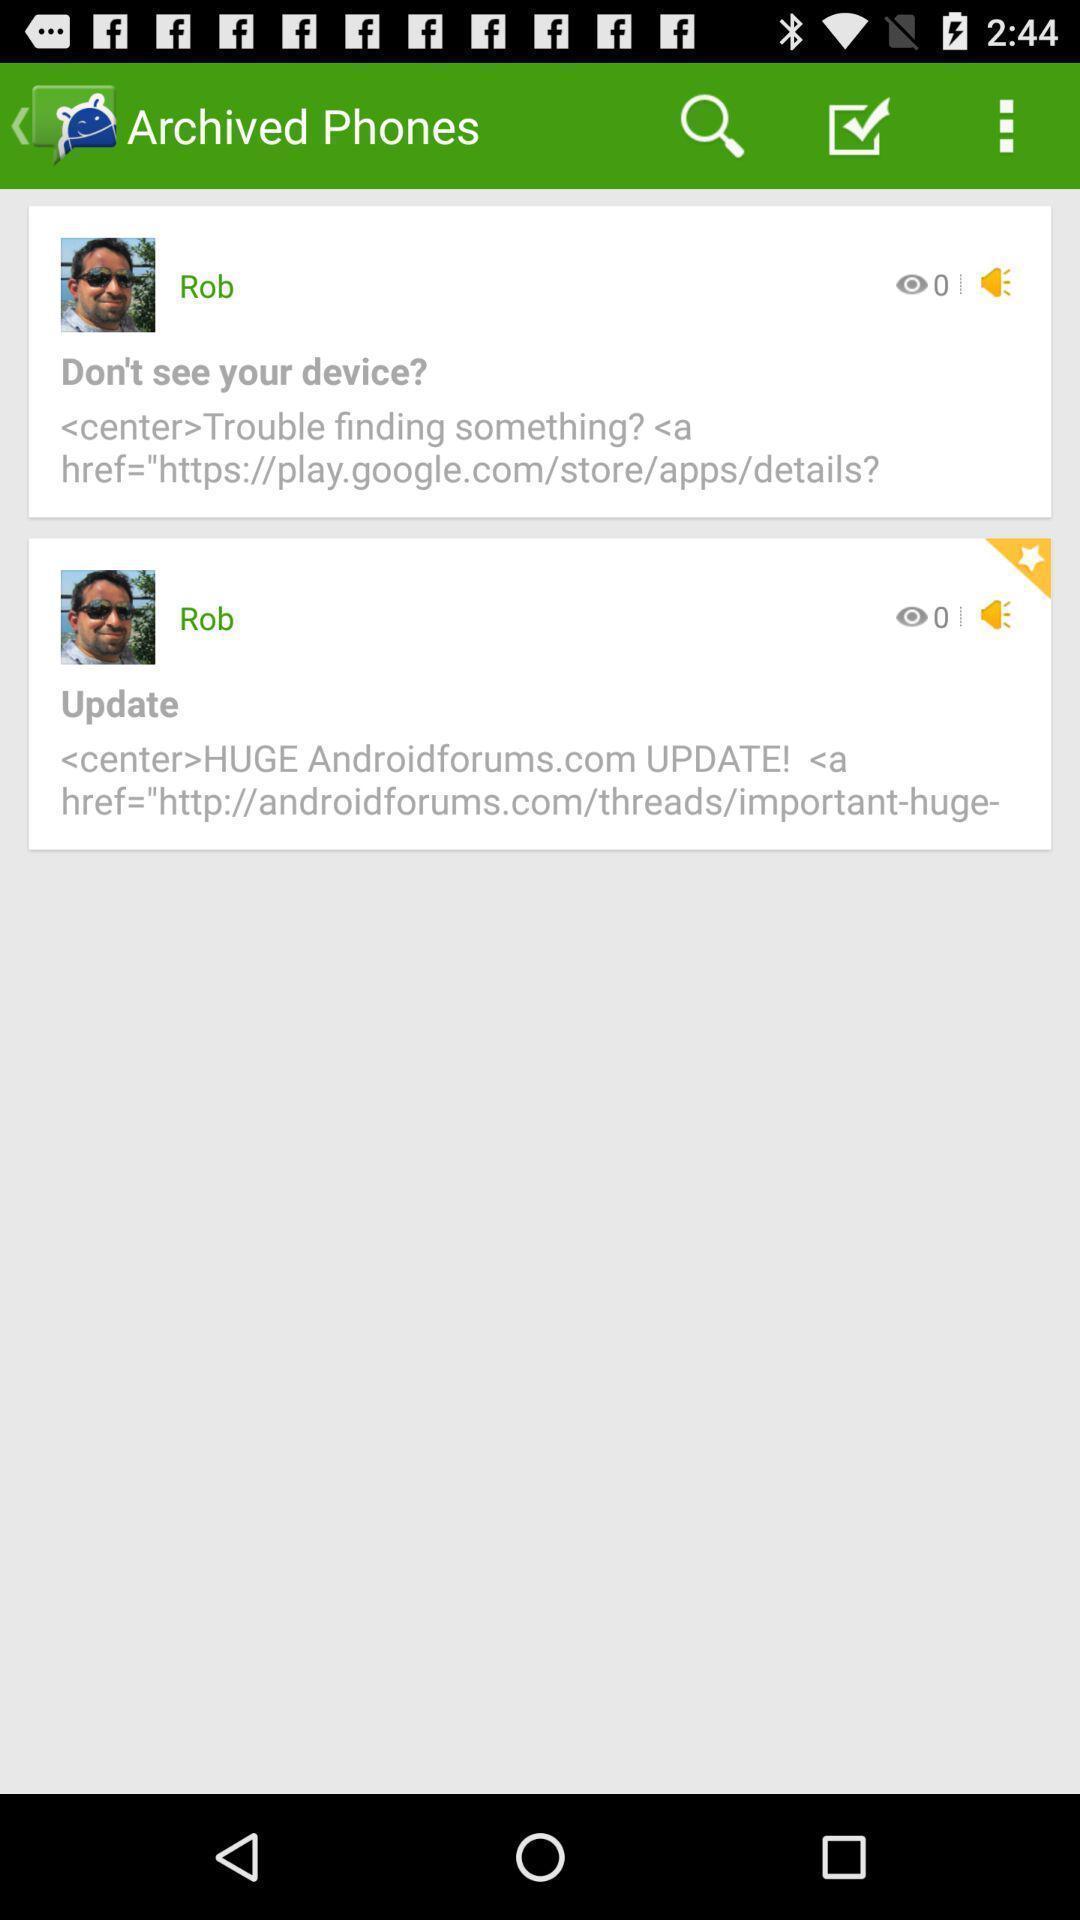Describe the visual elements of this screenshot. Various conversations displayed. 